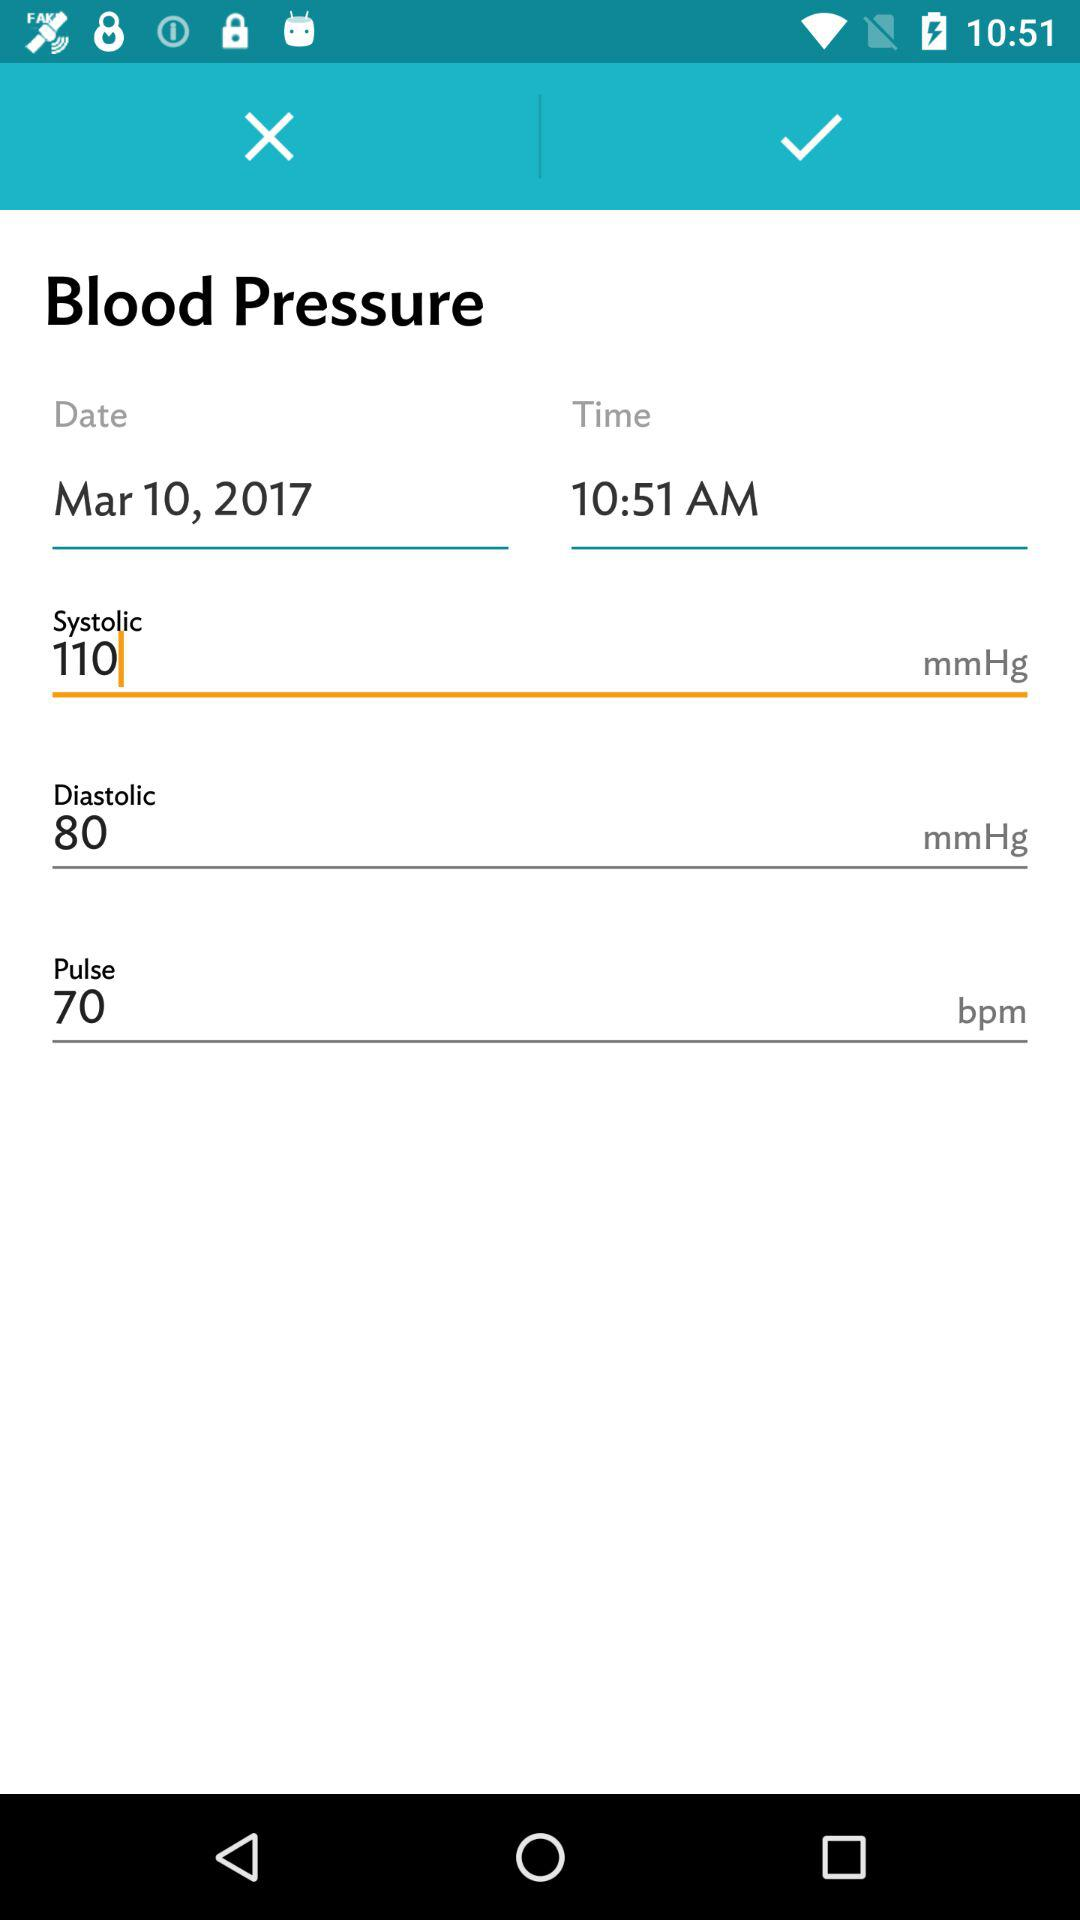What is the difference in blood pressure between the systolic and diastolic values?
Answer the question using a single word or phrase. 30 